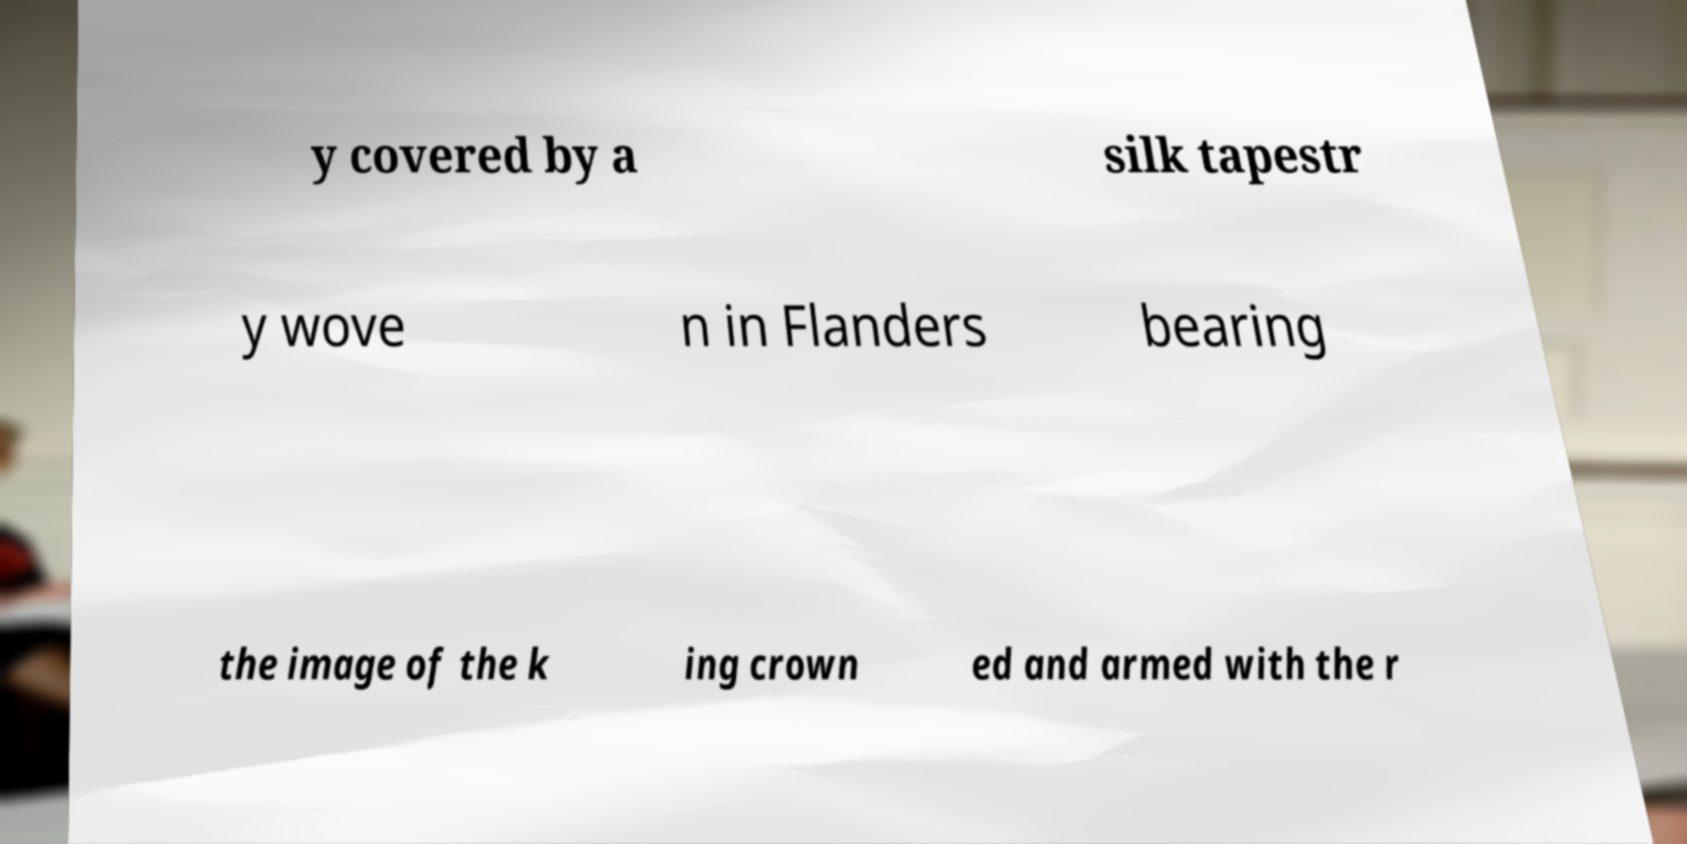For documentation purposes, I need the text within this image transcribed. Could you provide that? y covered by a silk tapestr y wove n in Flanders bearing the image of the k ing crown ed and armed with the r 